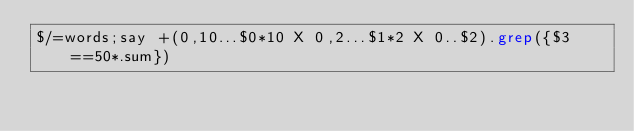<code> <loc_0><loc_0><loc_500><loc_500><_Perl_>$/=words;say +(0,10...$0*10 X 0,2...$1*2 X 0..$2).grep({$3==50*.sum})</code> 